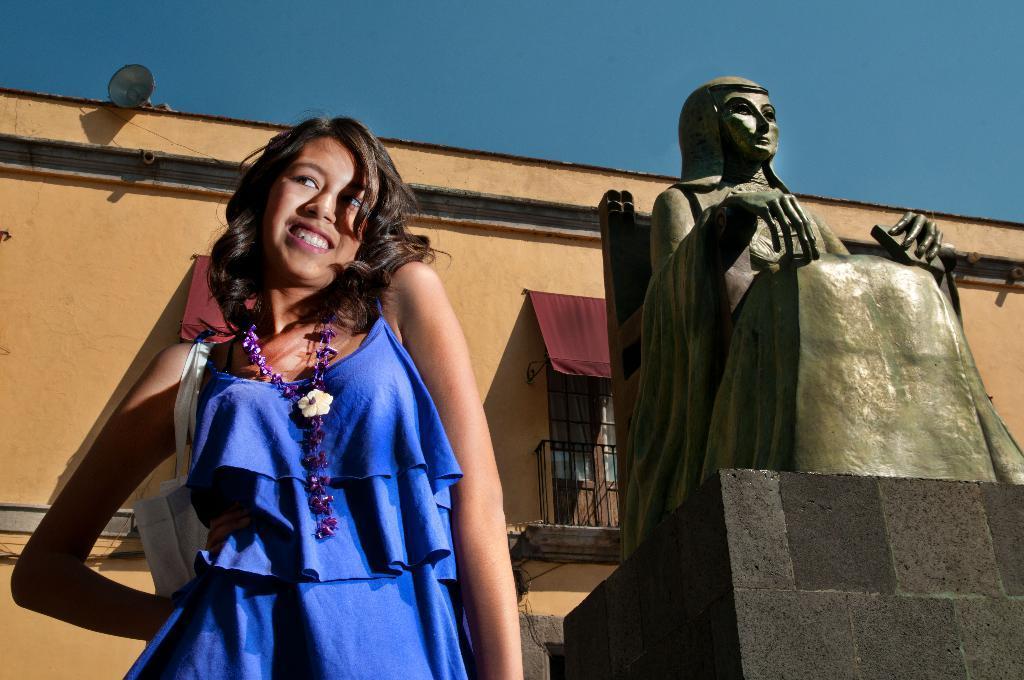In one or two sentences, can you explain what this image depicts? In this image, I can see the woman standing and smiling. This is the sculpture of a woman sitting on the chair. In the background, that looks like a building with a window. I think this is the sky. 